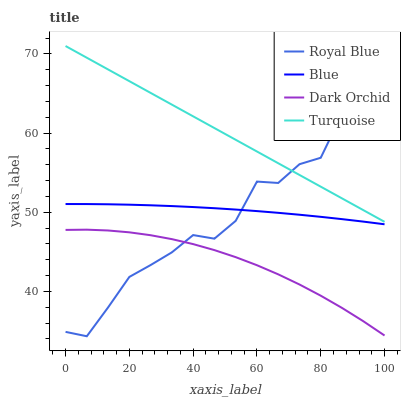Does Dark Orchid have the minimum area under the curve?
Answer yes or no. Yes. Does Turquoise have the maximum area under the curve?
Answer yes or no. Yes. Does Royal Blue have the minimum area under the curve?
Answer yes or no. No. Does Royal Blue have the maximum area under the curve?
Answer yes or no. No. Is Turquoise the smoothest?
Answer yes or no. Yes. Is Royal Blue the roughest?
Answer yes or no. Yes. Is Royal Blue the smoothest?
Answer yes or no. No. Is Turquoise the roughest?
Answer yes or no. No. Does Royal Blue have the lowest value?
Answer yes or no. Yes. Does Turquoise have the lowest value?
Answer yes or no. No. Does Turquoise have the highest value?
Answer yes or no. Yes. Does Royal Blue have the highest value?
Answer yes or no. No. Is Dark Orchid less than Turquoise?
Answer yes or no. Yes. Is Blue greater than Dark Orchid?
Answer yes or no. Yes. Does Blue intersect Royal Blue?
Answer yes or no. Yes. Is Blue less than Royal Blue?
Answer yes or no. No. Is Blue greater than Royal Blue?
Answer yes or no. No. Does Dark Orchid intersect Turquoise?
Answer yes or no. No. 